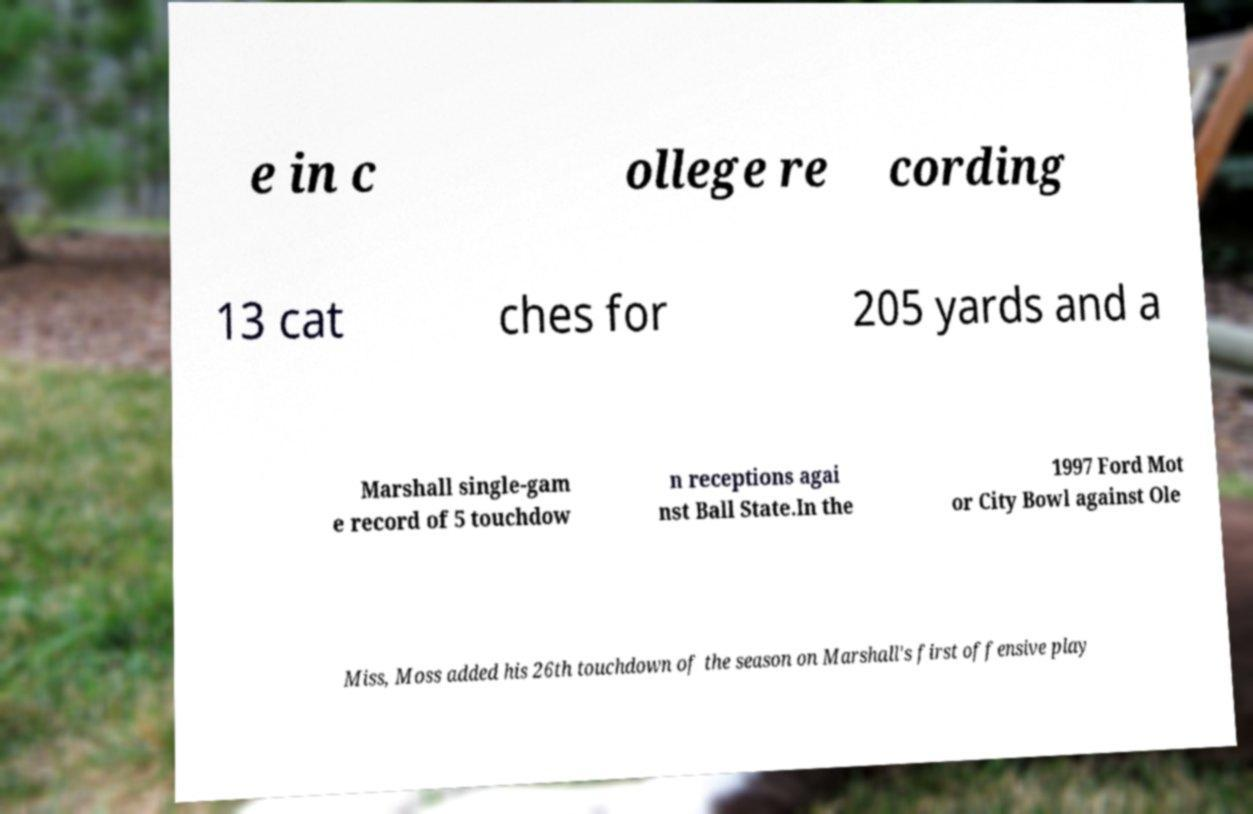Please identify and transcribe the text found in this image. e in c ollege re cording 13 cat ches for 205 yards and a Marshall single-gam e record of 5 touchdow n receptions agai nst Ball State.In the 1997 Ford Mot or City Bowl against Ole Miss, Moss added his 26th touchdown of the season on Marshall's first offensive play 